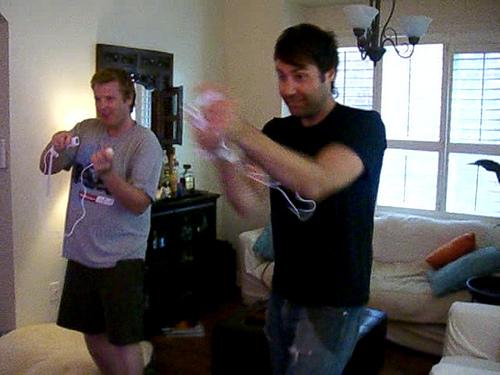Does this house have stairs?
Quick response, please. No. Are the people outdoors?
Concise answer only. No. Is the room dark?
Keep it brief. No. What room are they in?
Be succinct. Living room. What game are these people playing?
Write a very short answer. Wii. How is their attire similar?
Concise answer only. Tees. 